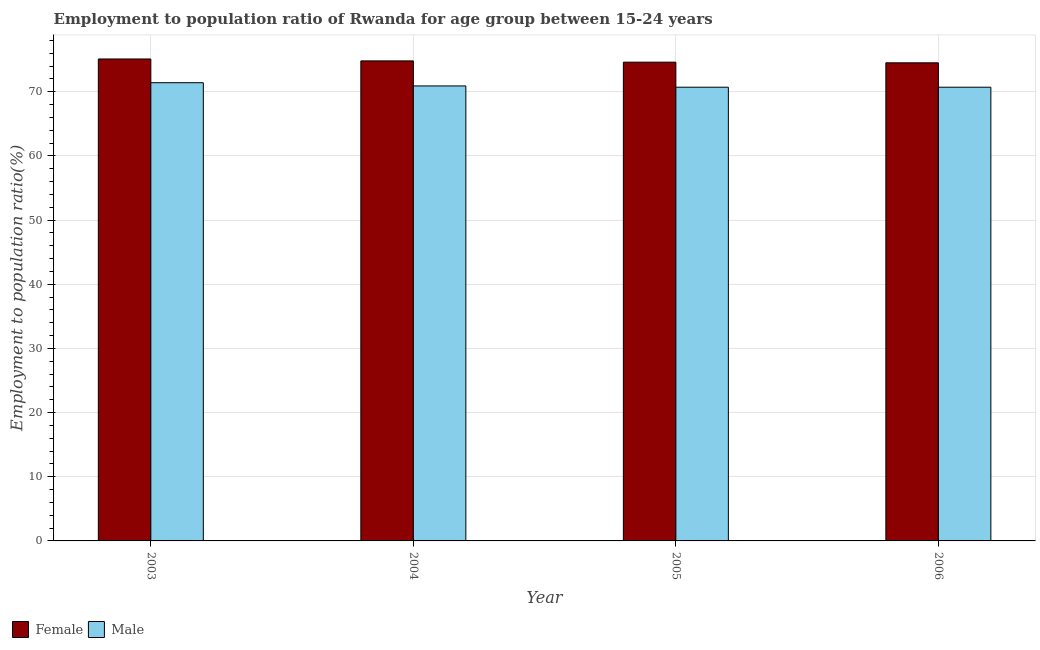Are the number of bars on each tick of the X-axis equal?
Provide a succinct answer. Yes. How many bars are there on the 2nd tick from the left?
Make the answer very short. 2. What is the label of the 3rd group of bars from the left?
Offer a terse response. 2005. In how many cases, is the number of bars for a given year not equal to the number of legend labels?
Provide a short and direct response. 0. What is the employment to population ratio(male) in 2005?
Your response must be concise. 70.7. Across all years, what is the maximum employment to population ratio(male)?
Provide a short and direct response. 71.4. Across all years, what is the minimum employment to population ratio(female)?
Give a very brief answer. 74.5. In which year was the employment to population ratio(male) maximum?
Make the answer very short. 2003. What is the total employment to population ratio(female) in the graph?
Provide a short and direct response. 299. What is the difference between the employment to population ratio(female) in 2005 and the employment to population ratio(male) in 2003?
Provide a short and direct response. -0.5. What is the average employment to population ratio(female) per year?
Your response must be concise. 74.75. In how many years, is the employment to population ratio(female) greater than 68 %?
Ensure brevity in your answer.  4. What is the ratio of the employment to population ratio(male) in 2004 to that in 2005?
Provide a succinct answer. 1. Is the difference between the employment to population ratio(male) in 2003 and 2005 greater than the difference between the employment to population ratio(female) in 2003 and 2005?
Your response must be concise. No. What is the difference between the highest and the lowest employment to population ratio(female)?
Make the answer very short. 0.6. In how many years, is the employment to population ratio(male) greater than the average employment to population ratio(male) taken over all years?
Provide a succinct answer. 1. Is the sum of the employment to population ratio(female) in 2004 and 2006 greater than the maximum employment to population ratio(male) across all years?
Your answer should be compact. Yes. What does the 1st bar from the right in 2004 represents?
Your answer should be very brief. Male. What is the difference between two consecutive major ticks on the Y-axis?
Offer a very short reply. 10. Are the values on the major ticks of Y-axis written in scientific E-notation?
Provide a succinct answer. No. How many legend labels are there?
Offer a terse response. 2. How are the legend labels stacked?
Offer a terse response. Horizontal. What is the title of the graph?
Keep it short and to the point. Employment to population ratio of Rwanda for age group between 15-24 years. What is the label or title of the X-axis?
Keep it short and to the point. Year. What is the Employment to population ratio(%) in Female in 2003?
Provide a succinct answer. 75.1. What is the Employment to population ratio(%) of Male in 2003?
Your response must be concise. 71.4. What is the Employment to population ratio(%) in Female in 2004?
Offer a very short reply. 74.8. What is the Employment to population ratio(%) in Male in 2004?
Offer a very short reply. 70.9. What is the Employment to population ratio(%) of Female in 2005?
Your answer should be very brief. 74.6. What is the Employment to population ratio(%) in Male in 2005?
Give a very brief answer. 70.7. What is the Employment to population ratio(%) of Female in 2006?
Give a very brief answer. 74.5. What is the Employment to population ratio(%) in Male in 2006?
Your response must be concise. 70.7. Across all years, what is the maximum Employment to population ratio(%) in Female?
Your answer should be very brief. 75.1. Across all years, what is the maximum Employment to population ratio(%) in Male?
Offer a very short reply. 71.4. Across all years, what is the minimum Employment to population ratio(%) of Female?
Offer a very short reply. 74.5. Across all years, what is the minimum Employment to population ratio(%) of Male?
Keep it short and to the point. 70.7. What is the total Employment to population ratio(%) of Female in the graph?
Your answer should be compact. 299. What is the total Employment to population ratio(%) in Male in the graph?
Offer a terse response. 283.7. What is the difference between the Employment to population ratio(%) of Male in 2003 and that in 2005?
Ensure brevity in your answer.  0.7. What is the difference between the Employment to population ratio(%) of Female in 2003 and that in 2006?
Ensure brevity in your answer.  0.6. What is the difference between the Employment to population ratio(%) of Male in 2003 and that in 2006?
Make the answer very short. 0.7. What is the difference between the Employment to population ratio(%) of Male in 2004 and that in 2005?
Keep it short and to the point. 0.2. What is the difference between the Employment to population ratio(%) of Female in 2004 and that in 2006?
Offer a very short reply. 0.3. What is the difference between the Employment to population ratio(%) in Male in 2004 and that in 2006?
Your answer should be compact. 0.2. What is the difference between the Employment to population ratio(%) in Female in 2005 and that in 2006?
Your answer should be compact. 0.1. What is the difference between the Employment to population ratio(%) in Male in 2005 and that in 2006?
Your answer should be very brief. 0. What is the difference between the Employment to population ratio(%) of Female in 2003 and the Employment to population ratio(%) of Male in 2005?
Ensure brevity in your answer.  4.4. What is the difference between the Employment to population ratio(%) of Female in 2003 and the Employment to population ratio(%) of Male in 2006?
Your answer should be compact. 4.4. What is the difference between the Employment to population ratio(%) in Female in 2005 and the Employment to population ratio(%) in Male in 2006?
Provide a succinct answer. 3.9. What is the average Employment to population ratio(%) in Female per year?
Make the answer very short. 74.75. What is the average Employment to population ratio(%) in Male per year?
Your response must be concise. 70.92. In the year 2006, what is the difference between the Employment to population ratio(%) in Female and Employment to population ratio(%) in Male?
Ensure brevity in your answer.  3.8. What is the ratio of the Employment to population ratio(%) in Female in 2003 to that in 2004?
Your answer should be very brief. 1. What is the ratio of the Employment to population ratio(%) of Male in 2003 to that in 2004?
Provide a short and direct response. 1.01. What is the ratio of the Employment to population ratio(%) of Female in 2003 to that in 2005?
Provide a short and direct response. 1.01. What is the ratio of the Employment to population ratio(%) in Male in 2003 to that in 2005?
Give a very brief answer. 1.01. What is the ratio of the Employment to population ratio(%) in Female in 2003 to that in 2006?
Make the answer very short. 1.01. What is the ratio of the Employment to population ratio(%) of Male in 2003 to that in 2006?
Ensure brevity in your answer.  1.01. What is the ratio of the Employment to population ratio(%) of Male in 2004 to that in 2005?
Offer a very short reply. 1. What is the difference between the highest and the second highest Employment to population ratio(%) in Female?
Provide a succinct answer. 0.3. What is the difference between the highest and the lowest Employment to population ratio(%) in Male?
Provide a short and direct response. 0.7. 